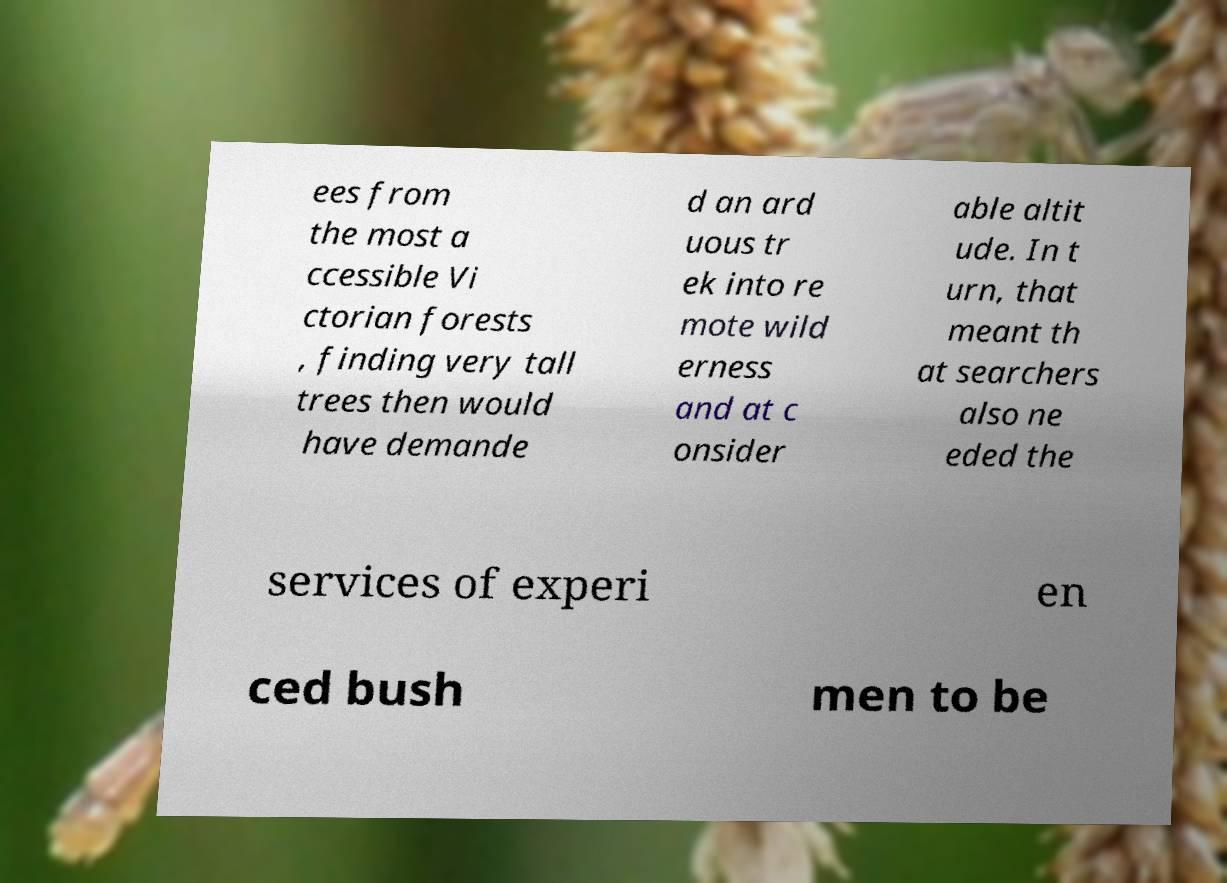Please identify and transcribe the text found in this image. ees from the most a ccessible Vi ctorian forests , finding very tall trees then would have demande d an ard uous tr ek into re mote wild erness and at c onsider able altit ude. In t urn, that meant th at searchers also ne eded the services of experi en ced bush men to be 